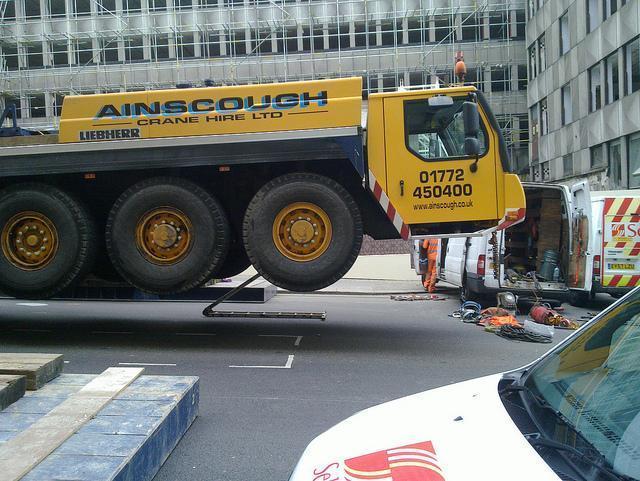How many wheels does this vehicle have?
Give a very brief answer. 6. How many cars are in the picture?
Give a very brief answer. 2. How many birds are on the branch?
Give a very brief answer. 0. 